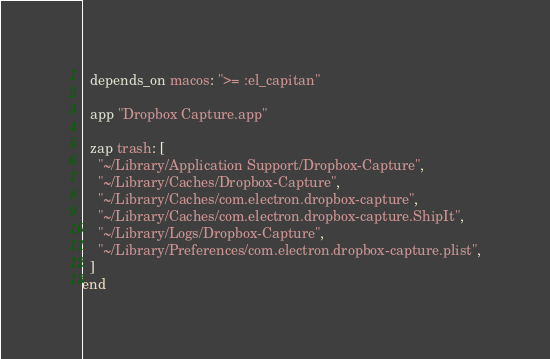<code> <loc_0><loc_0><loc_500><loc_500><_Ruby_>
  depends_on macos: ">= :el_capitan"

  app "Dropbox Capture.app"

  zap trash: [
    "~/Library/Application Support/Dropbox-Capture",
    "~/Library/Caches/Dropbox-Capture",
    "~/Library/Caches/com.electron.dropbox-capture",
    "~/Library/Caches/com.electron.dropbox-capture.ShipIt",
    "~/Library/Logs/Dropbox-Capture",
    "~/Library/Preferences/com.electron.dropbox-capture.plist",
  ]
end
</code> 